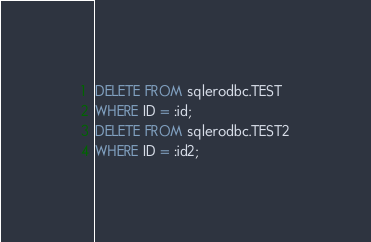<code> <loc_0><loc_0><loc_500><loc_500><_SQL_>DELETE FROM sqlerodbc.TEST
WHERE ID = :id;
DELETE FROM sqlerodbc.TEST2
WHERE ID = :id2;</code> 